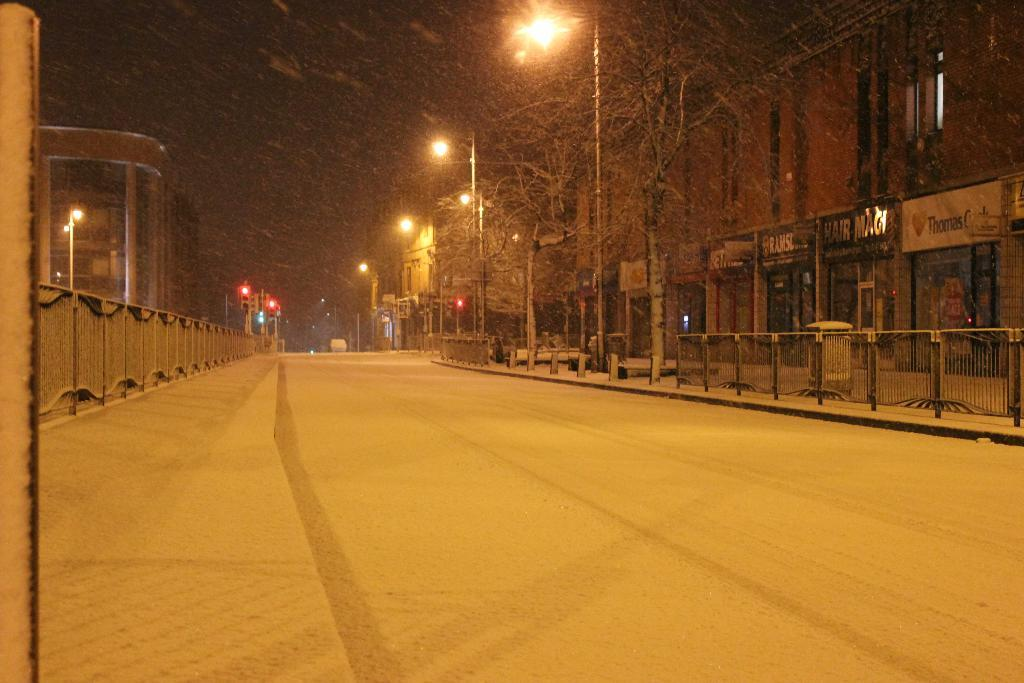What is the main feature of the image? There is a road in the image. What surrounds the road? There is fencing on both sides of the road. What can be seen attached to poles along the road? Lights are attached to poles along the road. What type of structures are visible in the image? There are buildings visible in the image. How would you describe the background of the image? The background of the image is dark in color. How many oranges are hanging from the fencing in the image? There are no oranges present in the image; the fencing surrounds the road. What type of respect is being shown in the image? There is no indication of respect being shown in the image; it features a road, fencing, lights, buildings, and a dark background. 